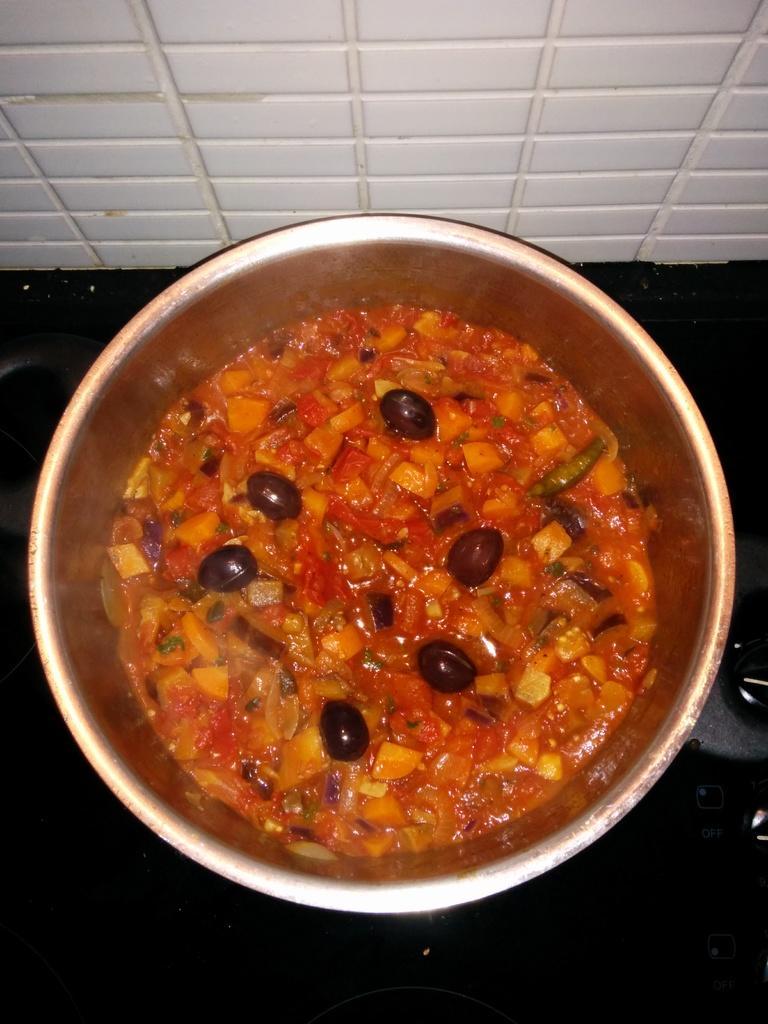Can you describe this image briefly? In this image we can see a food item in a bowl. 